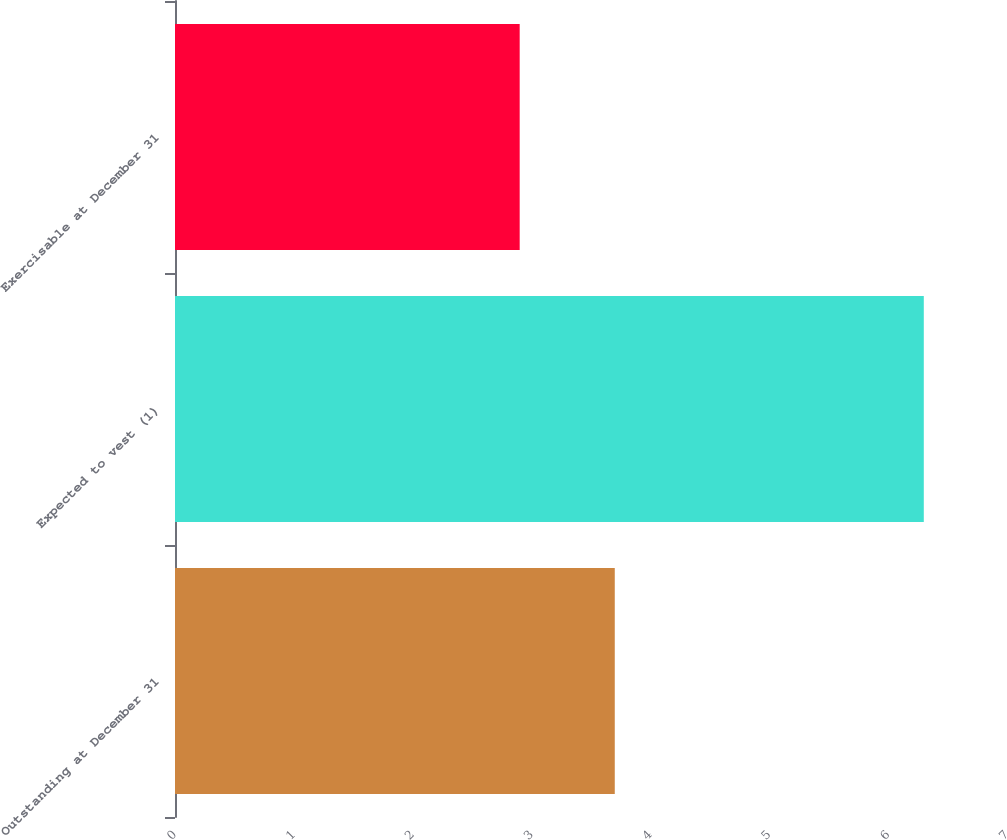Convert chart. <chart><loc_0><loc_0><loc_500><loc_500><bar_chart><fcel>Outstanding at December 31<fcel>Expected to vest (1)<fcel>Exercisable at December 31<nl><fcel>3.7<fcel>6.3<fcel>2.9<nl></chart> 